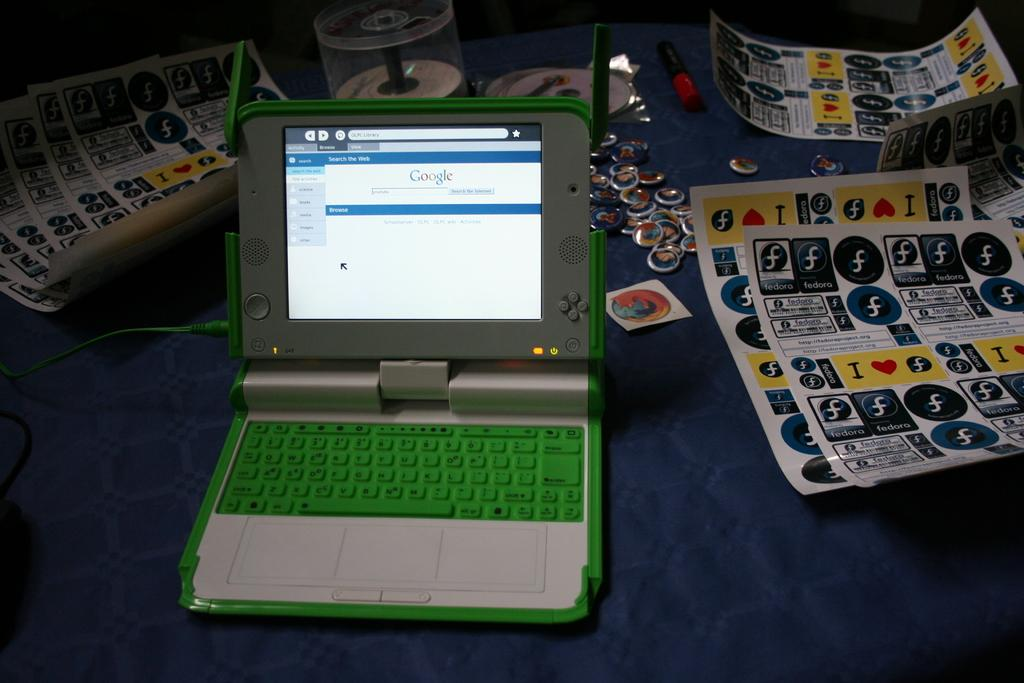<image>
Describe the image concisely. Stickers with the word Fedora written on them sit to the right of an electrical device. 